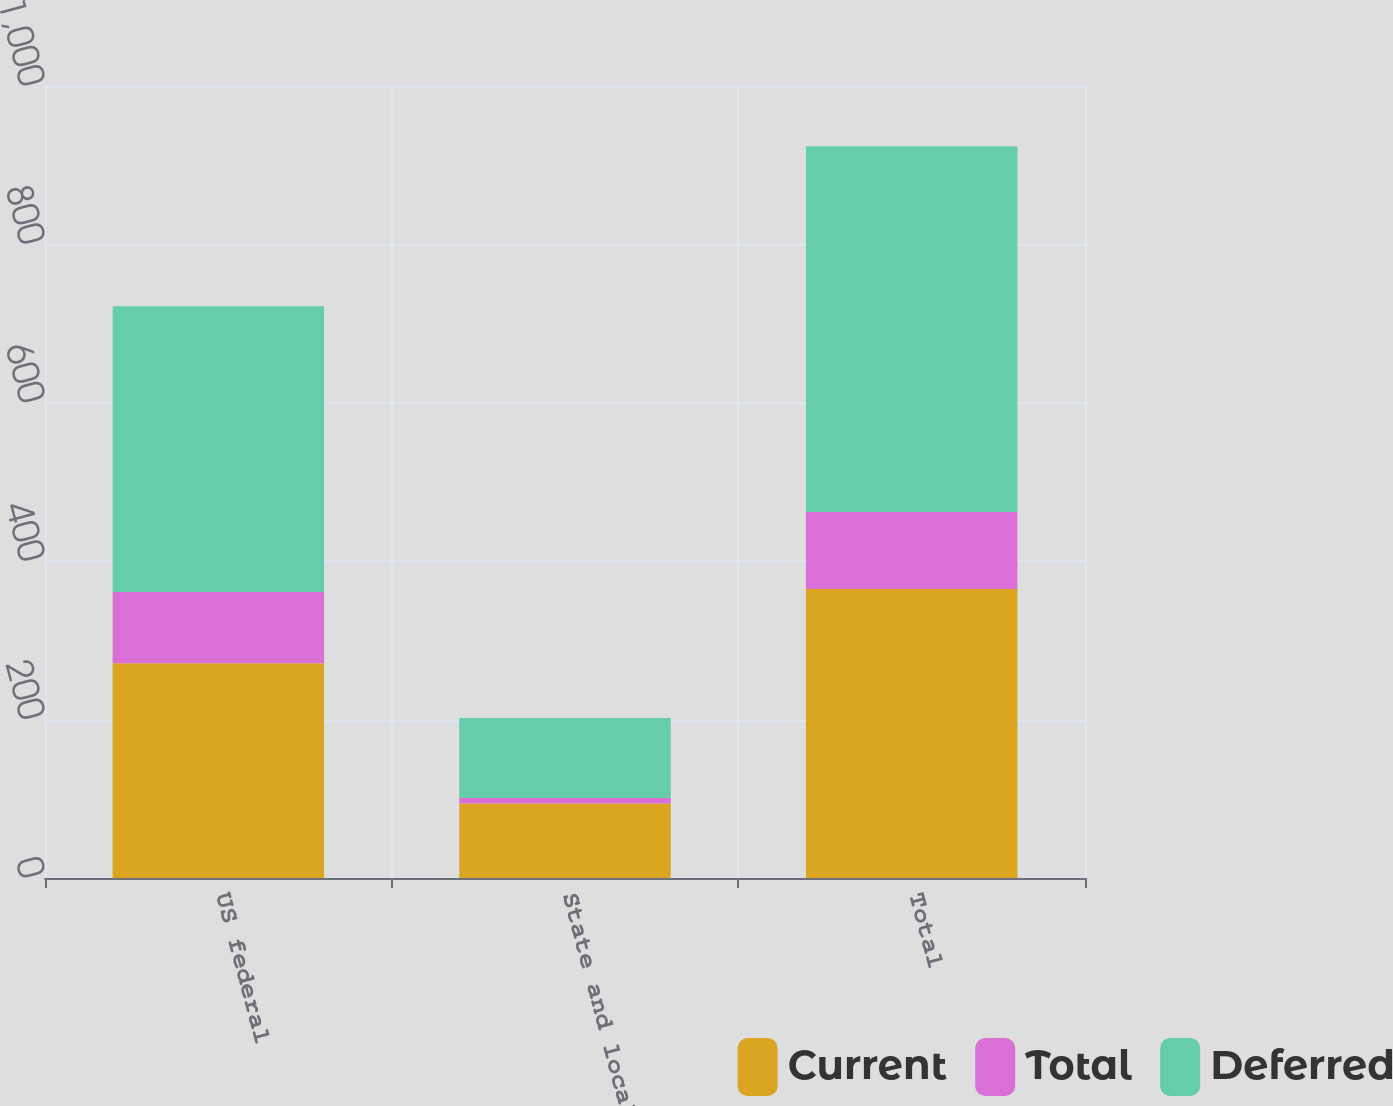Convert chart to OTSL. <chart><loc_0><loc_0><loc_500><loc_500><stacked_bar_chart><ecel><fcel>US federal<fcel>State and local<fcel>Total<nl><fcel>Current<fcel>271<fcel>94<fcel>365<nl><fcel>Total<fcel>90<fcel>7<fcel>97<nl><fcel>Deferred<fcel>361<fcel>101<fcel>462<nl></chart> 